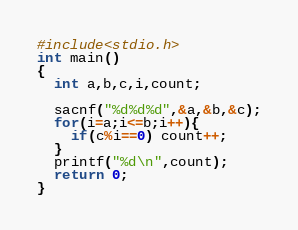<code> <loc_0><loc_0><loc_500><loc_500><_C_>#include<stdio.h>
int main()
{
  int a,b,c,i,count;

  sacnf("%d%d%d",&a,&b,&c);
  for(i=a;i<=b;i++){
    if(c%i==0) count++;
  }
  printf("%d\n",count);
  return 0;
}</code> 